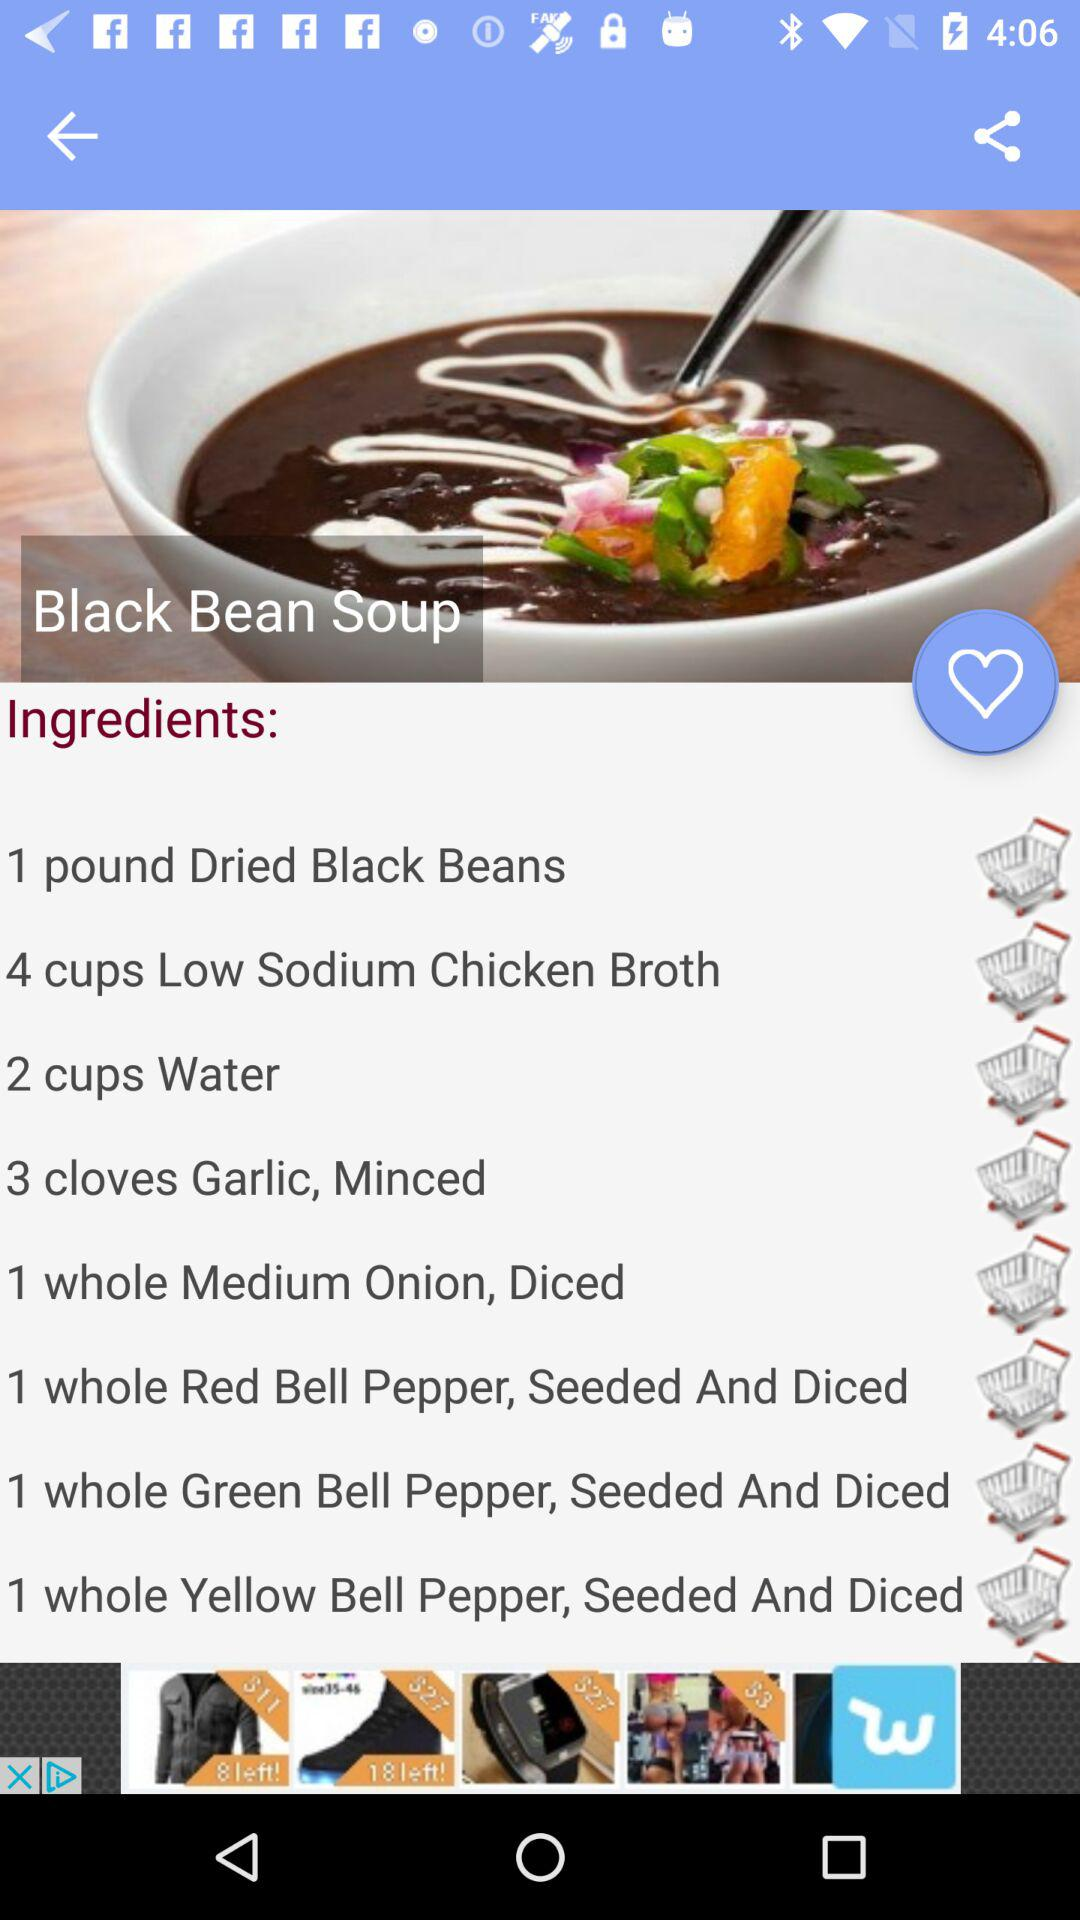What quantity of "Dried Black Beans" is needed for the recipe? The quantity of "Dried Black Beans" that is needed for the recipe is 1 pound. 